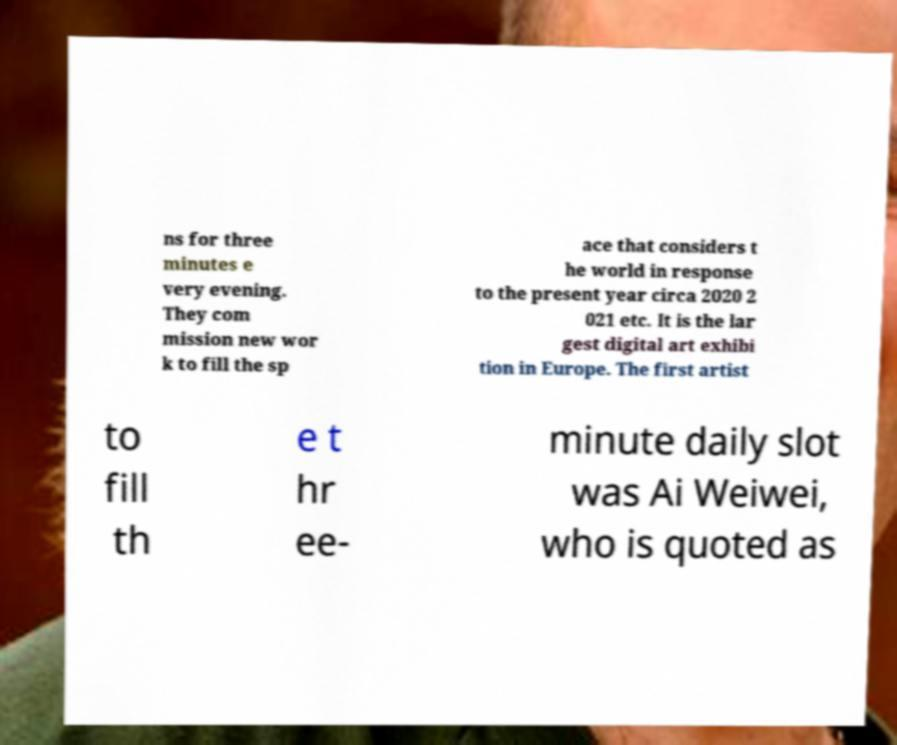Please read and relay the text visible in this image. What does it say? ns for three minutes e very evening. They com mission new wor k to fill the sp ace that considers t he world in response to the present year circa 2020 2 021 etc. It is the lar gest digital art exhibi tion in Europe. The first artist to fill th e t hr ee- minute daily slot was Ai Weiwei, who is quoted as 